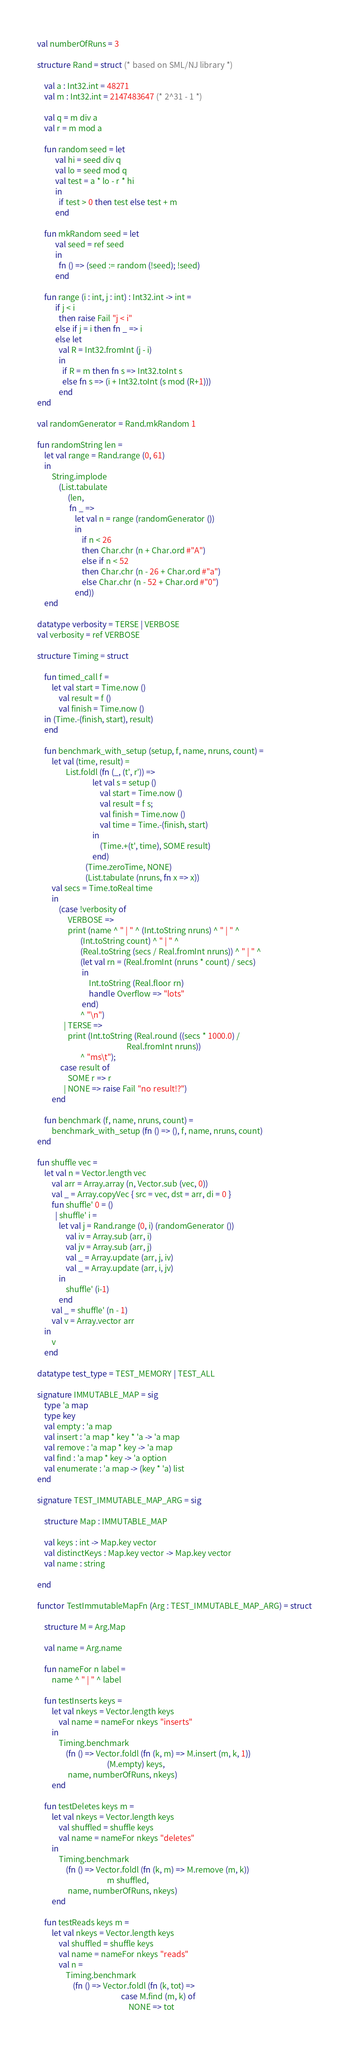Convert code to text. <code><loc_0><loc_0><loc_500><loc_500><_SML_>
val numberOfRuns = 3

structure Rand = struct (* based on SML/NJ library *)

    val a : Int32.int = 48271
    val m : Int32.int = 2147483647 (* 2^31 - 1 *)

    val q = m div a
    val r = m mod a

    fun random seed = let 
          val hi = seed div q
          val lo = seed mod q
          val test = a * lo - r * hi
          in
            if test > 0 then test else test + m
          end
                     
    fun mkRandom seed = let
          val seed = ref seed
          in
            fn () => (seed := random (!seed); !seed)
          end

    fun range (i : int, j : int) : Int32.int -> int =
          if j < i 
            then raise Fail "j < i"
          else if j = i then fn _ => i
          else let 
            val R = Int32.fromInt (j - i)
            in
              if R = m then fn s => Int32.toInt s
              else fn s => (i + Int32.toInt (s mod (R+1)))
            end
end

val randomGenerator = Rand.mkRandom 1

fun randomString len =
    let val range = Rand.range (0, 61)
    in
        String.implode
            (List.tabulate
                 (len,
                  fn _ =>
                     let val n = range (randomGenerator ())
                     in
                         if n < 26
                         then Char.chr (n + Char.ord #"A")
                         else if n < 52
                         then Char.chr (n - 26 + Char.ord #"a")
                         else Char.chr (n - 52 + Char.ord #"0")
                     end))
    end

datatype verbosity = TERSE | VERBOSE
val verbosity = ref VERBOSE               
        
structure Timing = struct

    fun timed_call f =
        let val start = Time.now ()
            val result = f ()
            val finish = Time.now ()
	in (Time.-(finish, start), result)
	end

    fun benchmark_with_setup (setup, f, name, nruns, count) =
        let val (time, result) =
                List.foldl (fn (_, (t', r')) =>
                               let val s = setup ()
                                   val start = Time.now ()
                                   val result = f s;
                                   val finish = Time.now ()
                                   val time = Time.-(finish, start)
                               in
                                   (Time.+(t', time), SOME result)
                               end)
                           (Time.zeroTime, NONE)
                           (List.tabulate (nruns, fn x => x))
	    val secs = Time.toReal time
        in
            (case !verbosity of
                 VERBOSE =>
                 print (name ^ " | " ^ (Int.toString nruns) ^ " | " ^
                        (Int.toString count) ^ " | " ^
                        (Real.toString (secs / Real.fromInt nruns)) ^ " | " ^
                        (let val rn = (Real.fromInt (nruns * count) / secs)
                         in
                             Int.toString (Real.floor rn)
                             handle Overflow => "lots"
                         end)
                        ^ "\n")
               | TERSE =>
                 print (Int.toString (Real.round ((secs * 1000.0) /
                                                  Real.fromInt nruns))
                        ^ "ms\t");
             case result of
                 SOME r => r
               | NONE => raise Fail "no result!?")
        end

    fun benchmark (f, name, nruns, count) =
        benchmark_with_setup (fn () => (), f, name, nruns, count)
end

fun shuffle vec =
    let val n = Vector.length vec
        val arr = Array.array (n, Vector.sub (vec, 0))
        val _ = Array.copyVec { src = vec, dst = arr, di = 0 }
        fun shuffle' 0 = ()
          | shuffle' i =
            let val j = Rand.range (0, i) (randomGenerator ())
                val iv = Array.sub (arr, i)
                val jv = Array.sub (arr, j)
                val _ = Array.update (arr, j, iv)
                val _ = Array.update (arr, i, jv)
            in
                shuffle' (i-1)
            end
        val _ = shuffle' (n - 1)
        val v = Array.vector arr
    in
        v
    end

datatype test_type = TEST_MEMORY | TEST_ALL
                       
signature IMMUTABLE_MAP = sig
    type 'a map
    type key
    val empty : 'a map
    val insert : 'a map * key * 'a -> 'a map
    val remove : 'a map * key -> 'a map
    val find : 'a map * key -> 'a option
    val enumerate : 'a map -> (key * 'a) list
end

signature TEST_IMMUTABLE_MAP_ARG = sig

    structure Map : IMMUTABLE_MAP

    val keys : int -> Map.key vector
    val distinctKeys : Map.key vector -> Map.key vector
    val name : string
                        
end
                                   
functor TestImmutableMapFn (Arg : TEST_IMMUTABLE_MAP_ARG) = struct

    structure M = Arg.Map

    val name = Arg.name
                      
    fun nameFor n label =
        name ^ " | " ^ label
                      
    fun testInserts keys =
        let val nkeys = Vector.length keys
            val name = nameFor nkeys "inserts"
        in
            Timing.benchmark
                (fn () => Vector.foldl (fn (k, m) => M.insert (m, k, 1))
                                       (M.empty) keys,
                 name, numberOfRuns, nkeys)
        end
    
    fun testDeletes keys m =
        let val nkeys = Vector.length keys
            val shuffled = shuffle keys
            val name = nameFor nkeys "deletes"
        in
            Timing.benchmark
                (fn () => Vector.foldl (fn (k, m) => M.remove (m, k))
                                       m shuffled,
                 name, numberOfRuns, nkeys)
        end
    
    fun testReads keys m =
        let val nkeys = Vector.length keys
            val shuffled = shuffle keys
            val name = nameFor nkeys "reads"
            val n = 
                Timing.benchmark
                    (fn () => Vector.foldl (fn (k, tot) =>
                                               case M.find (m, k) of
                                                   NONE => tot</code> 